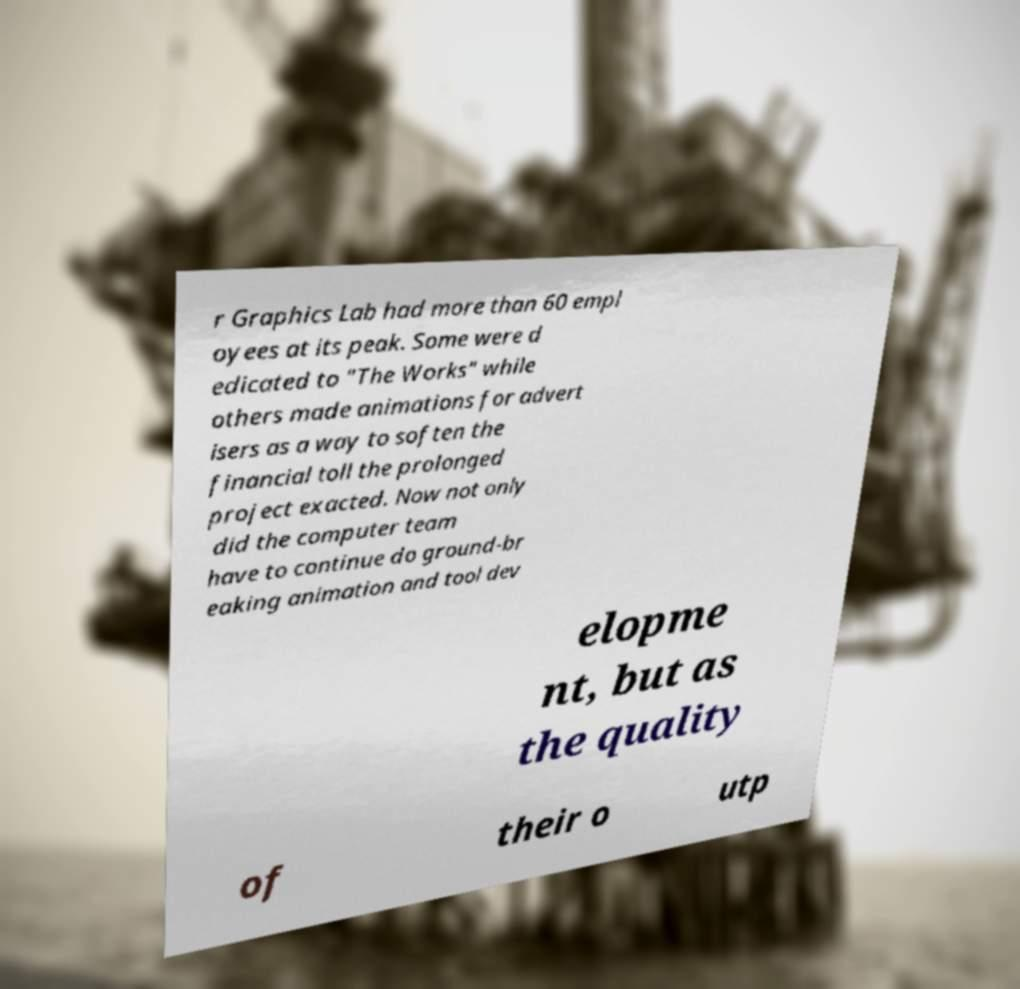Can you read and provide the text displayed in the image?This photo seems to have some interesting text. Can you extract and type it out for me? r Graphics Lab had more than 60 empl oyees at its peak. Some were d edicated to "The Works" while others made animations for advert isers as a way to soften the financial toll the prolonged project exacted. Now not only did the computer team have to continue do ground-br eaking animation and tool dev elopme nt, but as the quality of their o utp 